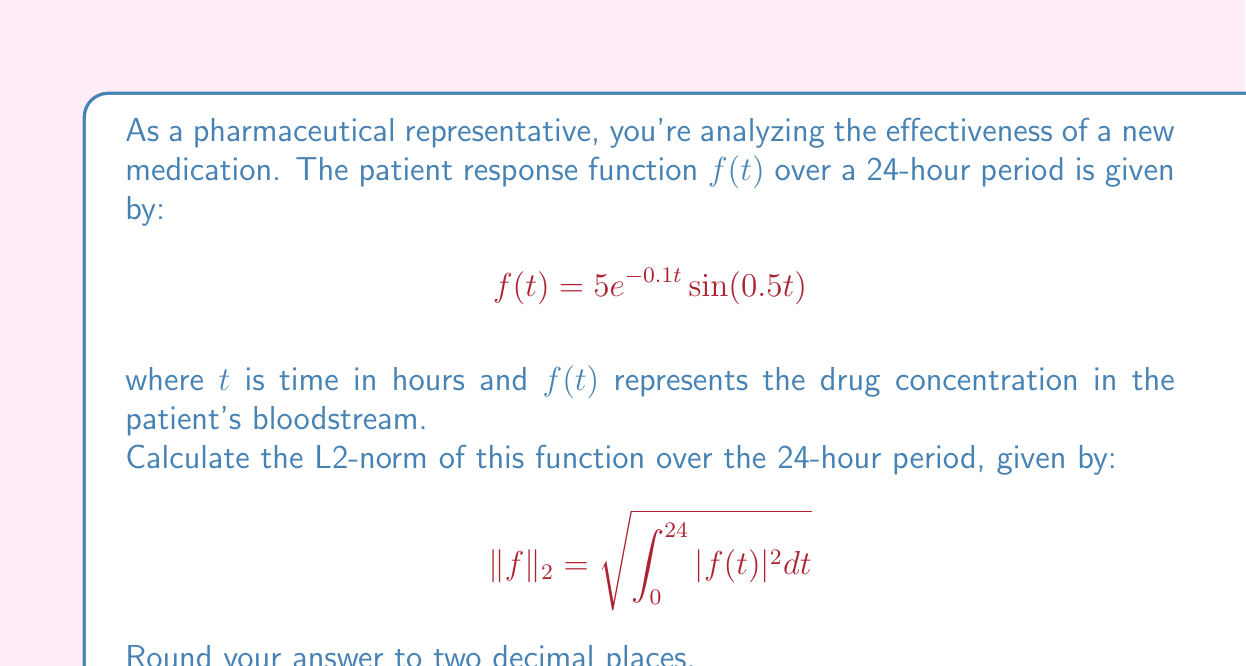Teach me how to tackle this problem. To calculate the L2-norm, we need to follow these steps:

1) First, we square the function:
   $|f(t)|^2 = (5e^{-0.1t}\sin(0.5t))^2 = 25e^{-0.2t}\sin^2(0.5t)$

2) Now, we need to integrate this from 0 to 24:
   $$\int_0^{24} 25e^{-0.2t}\sin^2(0.5t) dt$$

3) This integral is complex, so we'll use the identity:
   $\sin^2(x) = \frac{1 - \cos(2x)}{2}$

4) Substituting this in:
   $$\int_0^{24} 25e^{-0.2t}\left(\frac{1 - \cos(t)}{2}\right) dt$$

5) This can be split into two integrals:
   $$\frac{25}{2}\int_0^{24} e^{-0.2t} dt - \frac{25}{2}\int_0^{24} e^{-0.2t}\cos(t) dt$$

6) The first integral is straightforward:
   $$\frac{25}{2}\left[-5e^{-0.2t}\right]_0^{24} = \frac{25}{2}(5 - 5e^{-4.8}) \approx 62.4959$$

7) The second integral is more complex and requires numerical integration. Using a computational tool, we get:
   $$\frac{25}{2}\int_0^{24} e^{-0.2t}\cos(t) dt \approx 10.4168$$

8) Subtracting these results:
   $62.4959 - 10.4168 = 52.0791$

9) Finally, we take the square root:
   $\sqrt{52.0791} \approx 7.22$
Answer: $7.22$ 